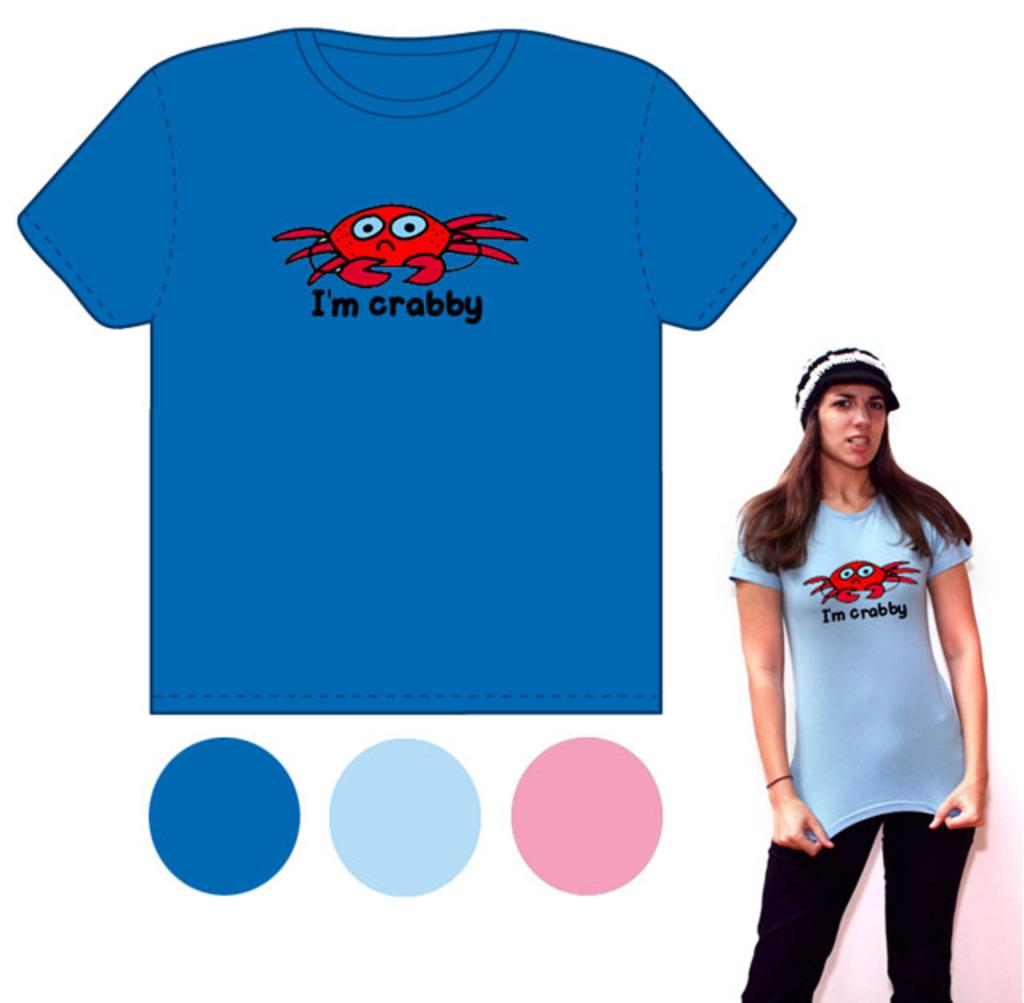<image>
Render a clear and concise summary of the photo. a blue shirt with a crab on it that says crabby 